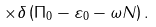Convert formula to latex. <formula><loc_0><loc_0><loc_500><loc_500>\times \delta \left ( \Pi _ { 0 } - \varepsilon _ { 0 } - \omega N \right ) .</formula> 